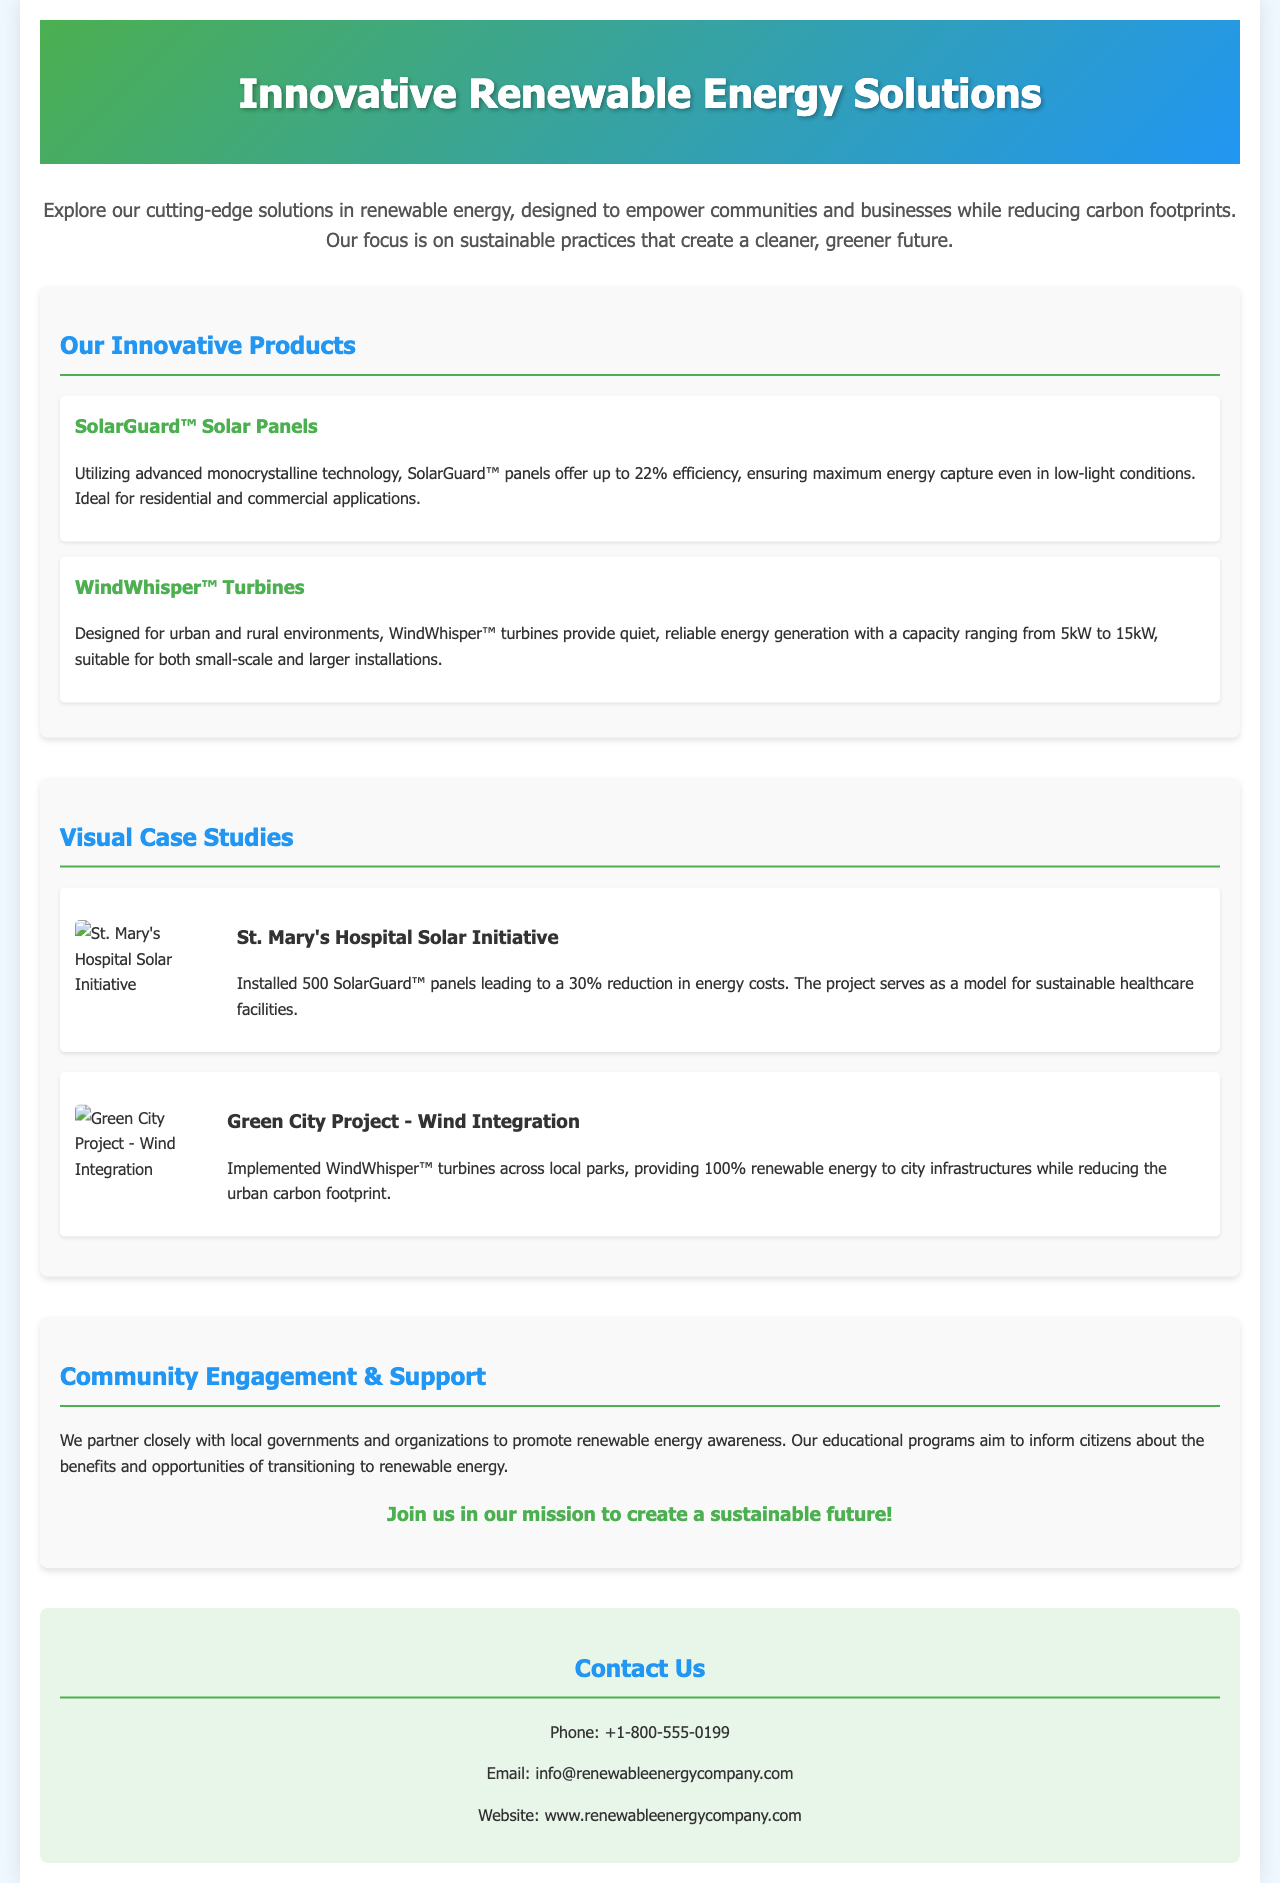What is the name of the first product listed? The first product listed in the document under "Our Innovative Products" is SolarGuard™ Solar Panels.
Answer: SolarGuard™ Solar Panels What is the efficiency percentage of SolarGuard™ panels? The document states that SolarGuard™ panels offer up to 22% efficiency.
Answer: 22% How many SolarGuard™ panels were installed at St. Mary's Hospital? According to the visual case study, St. Mary's Hospital had 500 SolarGuard™ panels installed.
Answer: 500 What is the capacity range for WindWhisper™ turbines? The document mentions that WindWhisper™ turbines have a capacity ranging from 5kW to 15kW.
Answer: 5kW to 15kW What percentage reduction in energy costs did St. Mary's Hospital achieve? The case study for St. Mary's Hospital states a 30% reduction in energy costs.
Answer: 30% What is the main purpose of the community engagement programs mentioned? The document indicates that the purpose of community engagement programs is to promote renewable energy awareness.
Answer: Promote renewable energy awareness Which project provides renewable energy to city infrastructures? The Green City Project - Wind Integration provides renewable energy to city infrastructures.
Answer: Green City Project - Wind Integration What type of visual content is included in the document? The document includes visual case studies featuring images of projects to support the descriptions.
Answer: Visual case studies What is the contact phone number listed? The document provides a contact phone number of +1-800-555-0199.
Answer: +1-800-555-0199 